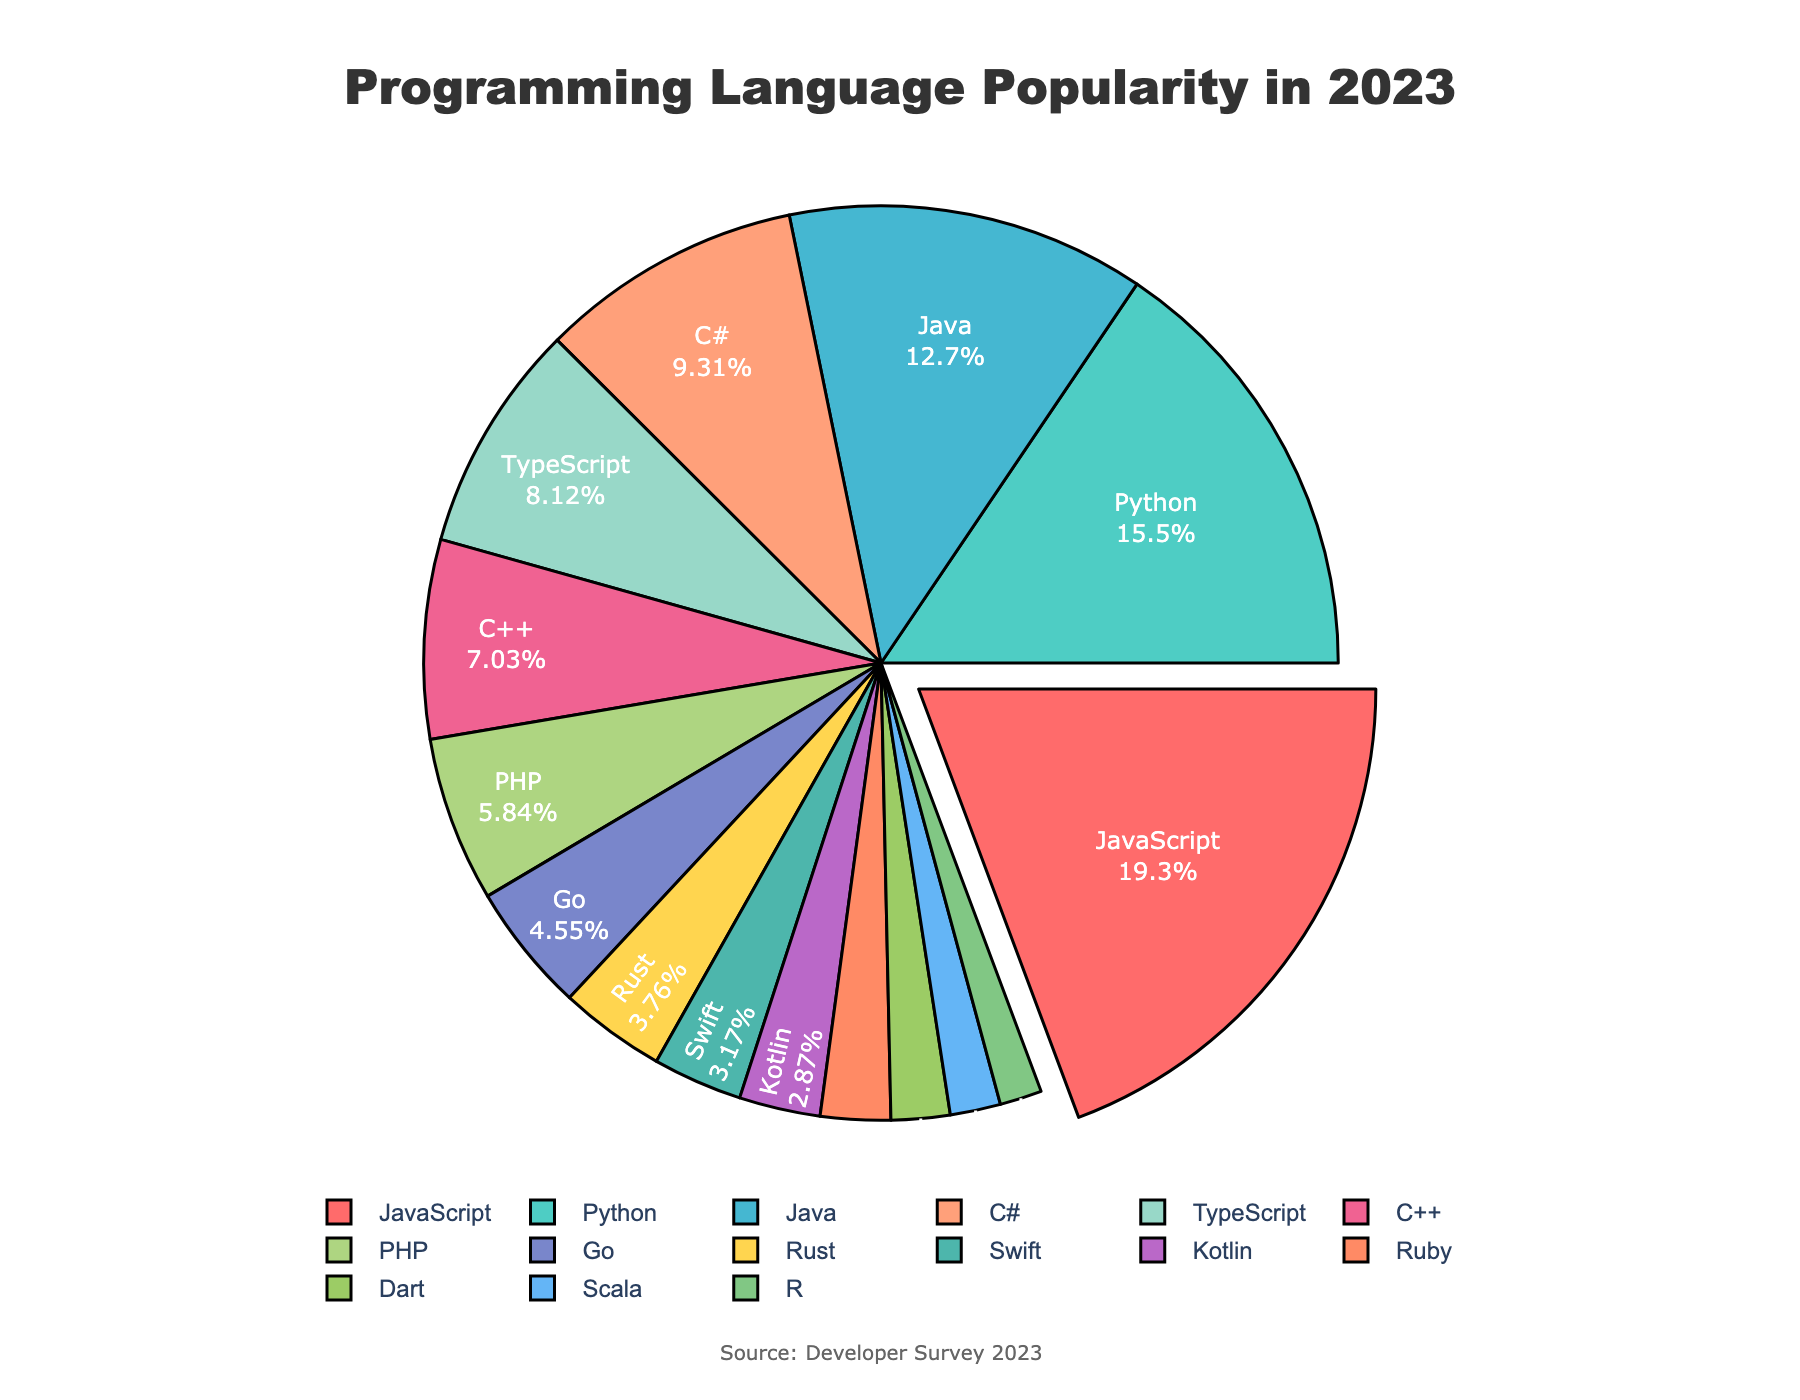Which programming language is the most popular among developers in 2023? By observing the largest segment of the pie chart with the highest percentage, JavaScript is identified as the most popular language with 19.5% of developers using it.
Answer: JavaScript Which two programming languages have the closest popularity percentages? By comparing the percentages of all the segments, Rust (3.8%) and Swift (3.2%) have the closest popularity percentages.
Answer: Rust and Swift What is the total combined percentage of developers using Python and C#? Add the percentage of Python (15.7%) and C# (9.4%) to get the total combined percentage: 15.7 + 9.4 = 25.1%.
Answer: 25.1% Which programming languages have a lower percentage than Go in 2023? Identify the languages with percentages less than Go's 4.6%: Rust (3.8%), Swift (3.2%), Kotlin (2.9%), Ruby (2.5%), Dart (2.1%), Scala (1.8%), and R (1.5%).
Answer: Rust, Swift, Kotlin, Ruby, Dart, Scala, R What percentage of developers use neither JavaScript, Python, nor Java? Subtract the percentages of JavaScript (19.5%), Python (15.7%), and Java (12.8%) from 100%: 100 - (19.5 + 15.7 + 12.8) = 52%.
Answer: 52% How many languages have a percentage higher than TypeScript? Find the number of languages with a greater percentage than TypeScript's 8.2%: JavaScript (19.5%), Python (15.7%), and Java (12.8%) and C# (9.4%) – totaling 4 languages.
Answer: 4 Which language has the smallest segment in the pie chart and what is its percentage? Identify the language with the smallest segment based on percentage: R, which has 1.5%.
Answer: R, 1.5% What is the difference in popularity percentage between the most and the least popular languages? Subtract the smallest percentage (R at 1.5%) from the largest (JavaScript at 19.5%): 19.5 - 1.5 = 18%.
Answer: 18% What visual element is used to highlight the most popular programming language in the pie chart? The most popular programming language (JavaScript) segment is visually highlighted by being slightly pulled out from the rest of the pie chart, creating a distinctive visual separation.
Answer: Pulled out segment If you combine the percentages of the three least popular languages, what would their total be? Add the percentages of the three least popular languages: Scala (1.8%), R (1.5%), and Dart (2.1%): 1.8 + 1.5 + 2.1 = 5.4%.
Answer: 5.4% 